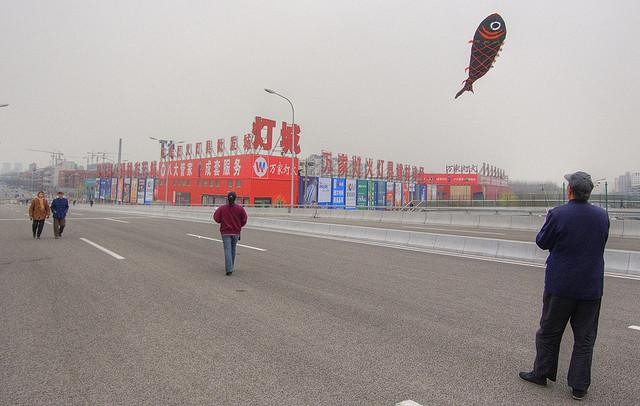What is the giant fish in the air? Please explain your reasoning. kite. The giant fish is flying like a kite. 